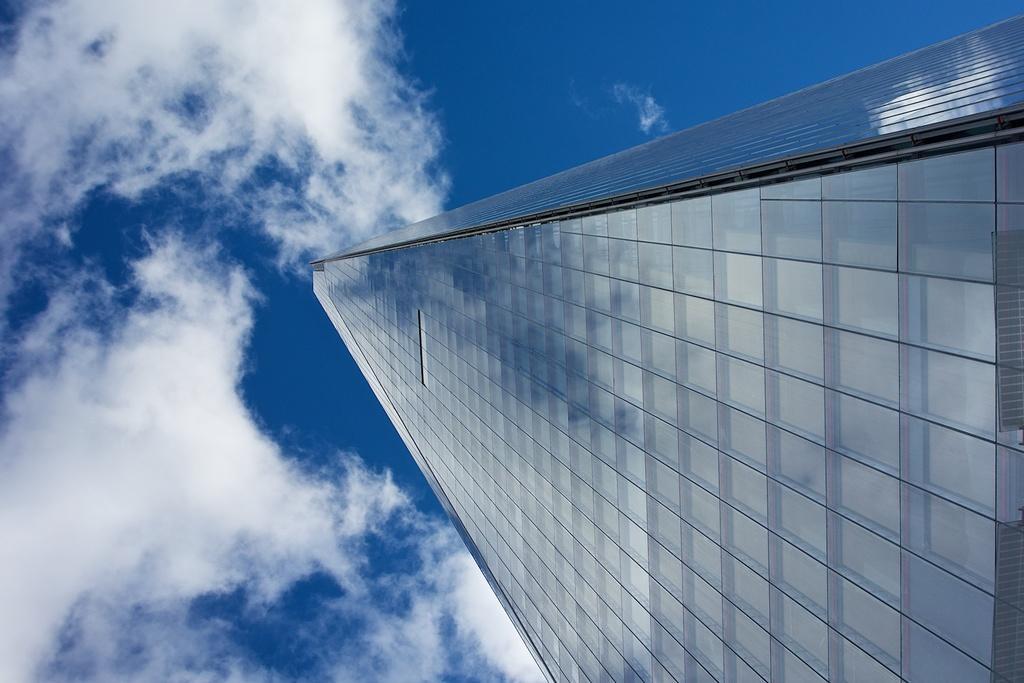Can you describe this image briefly? There is a building on the right side. In the background there is sky with clouds. 